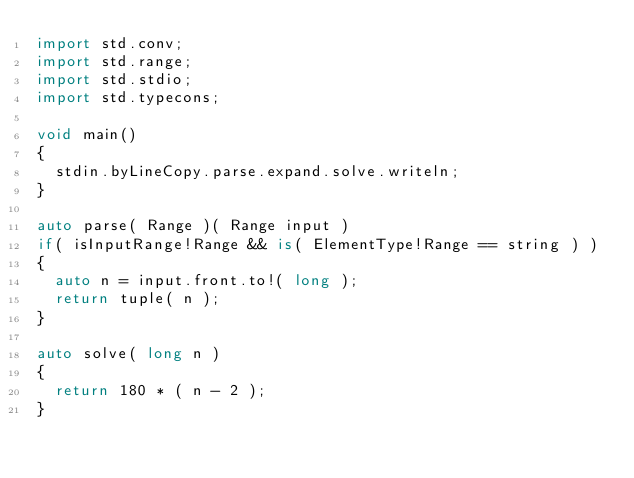<code> <loc_0><loc_0><loc_500><loc_500><_D_>import std.conv;
import std.range;
import std.stdio;
import std.typecons;

void main()
{
	stdin.byLineCopy.parse.expand.solve.writeln;
}

auto parse( Range )( Range input )
if( isInputRange!Range && is( ElementType!Range == string ) )
{
	auto n = input.front.to!( long );
	return tuple( n );
}

auto solve( long n )
{
	return 180 * ( n - 2 );
}
</code> 